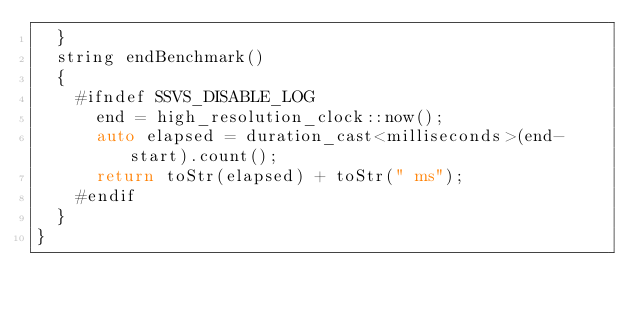Convert code to text. <code><loc_0><loc_0><loc_500><loc_500><_C++_>	}
	string endBenchmark()
	{
		#ifndef SSVS_DISABLE_LOG
			end = high_resolution_clock::now();
			auto elapsed = duration_cast<milliseconds>(end-start).count();
			return toStr(elapsed) + toStr(" ms");
		#endif
	}
}

</code> 